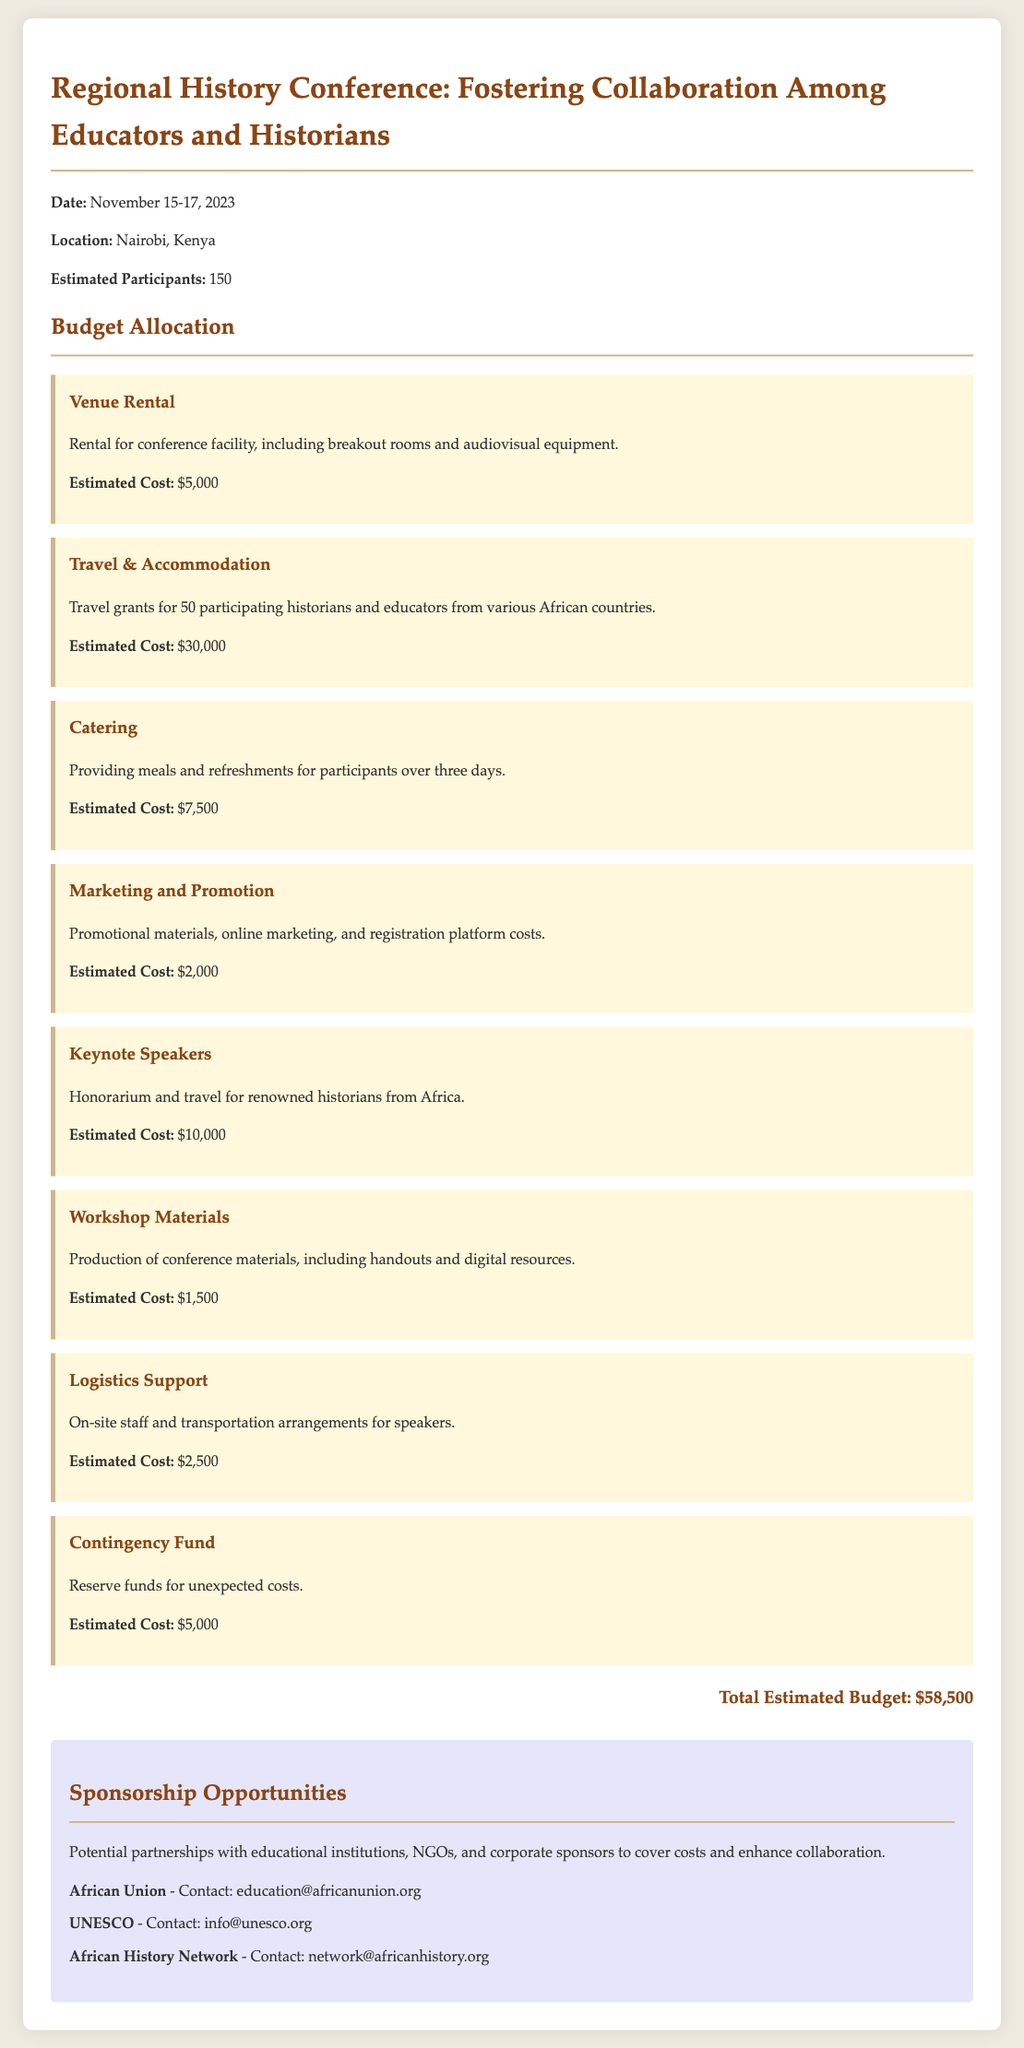What is the date of the conference? The conference is scheduled for November 15-17, 2023, as stated in the document.
Answer: November 15-17, 2023 Where will the conference be held? The document specifies that the location of the conference is Nairobi, Kenya.
Answer: Nairobi, Kenya How many estimated participants are there? The document mentions that there are 150 estimated participants expected at the conference.
Answer: 150 What is the estimated cost for travel and accommodation? The document lists the estimated cost for travel and accommodation as $30,000.
Answer: $30,000 What is the title of the conference? The document provides the title of the conference as 'Regional History Conference: Fostering Collaboration Among Educators and Historians.'
Answer: Regional History Conference: Fostering Collaboration Among Educators and Historians What is the purpose of the contingency fund? The document indicates that the contingency fund is meant for reserve funds for unexpected costs.
Answer: Unexpected costs How much is allocated for keynote speakers? The document states that the estimated cost allocated for keynote speakers is $10,000.
Answer: $10,000 What type of support is included in logistics support? The document mentions that logistics support includes on-site staff and transportation arrangements for speakers.
Answer: On-site staff and transportation arrangements What is the total estimated budget for the conference? The total estimated budget is calculated from the summation of all budget items listed in the document.
Answer: $58,500 Who are the potential sponsors listed? The document lists potential sponsors including African Union, UNESCO, and African History Network.
Answer: African Union, UNESCO, African History Network 